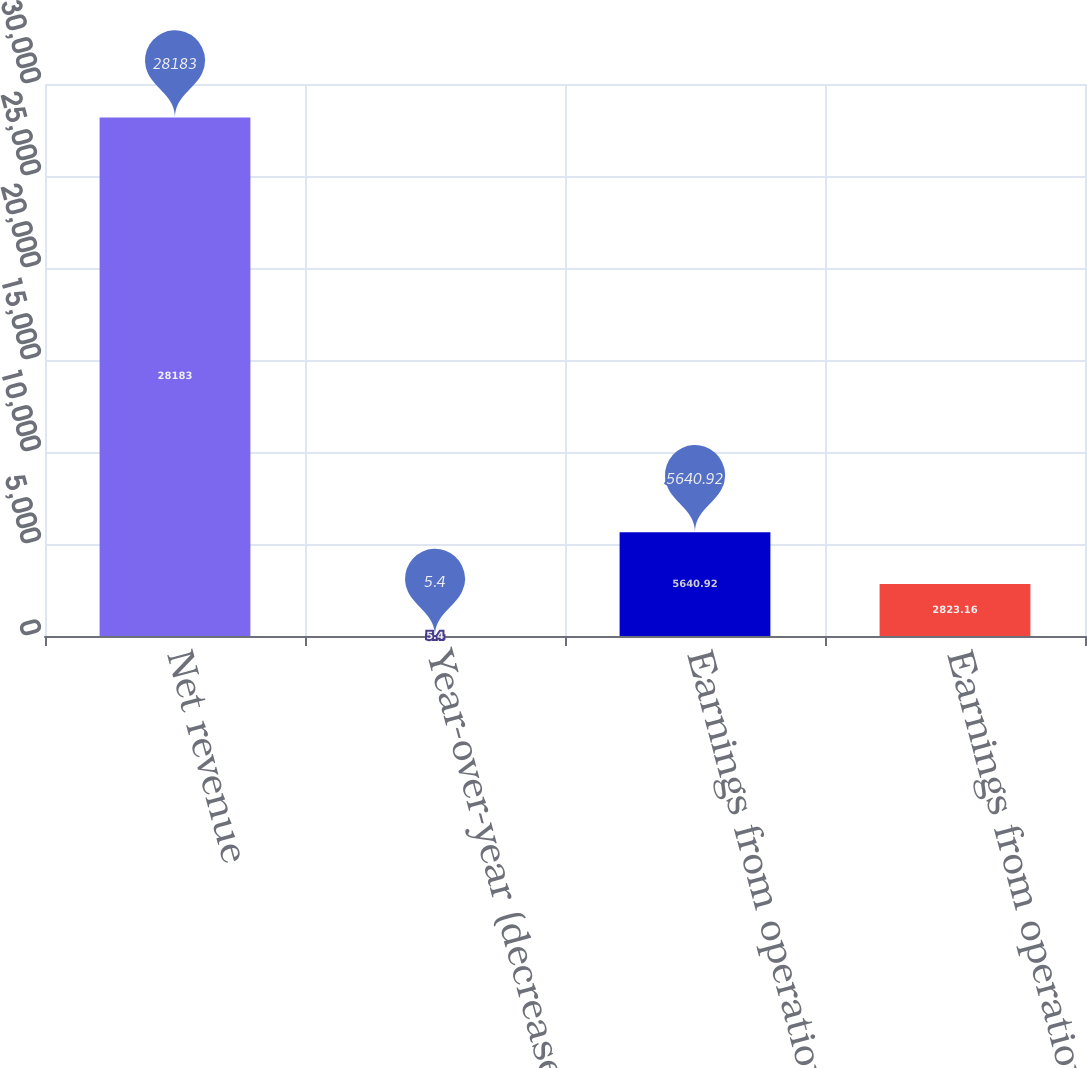Convert chart. <chart><loc_0><loc_0><loc_500><loc_500><bar_chart><fcel>Net revenue<fcel>Year-over-year (decrease)<fcel>Earnings from operations<fcel>Earnings from operations as a<nl><fcel>28183<fcel>5.4<fcel>5640.92<fcel>2823.16<nl></chart> 